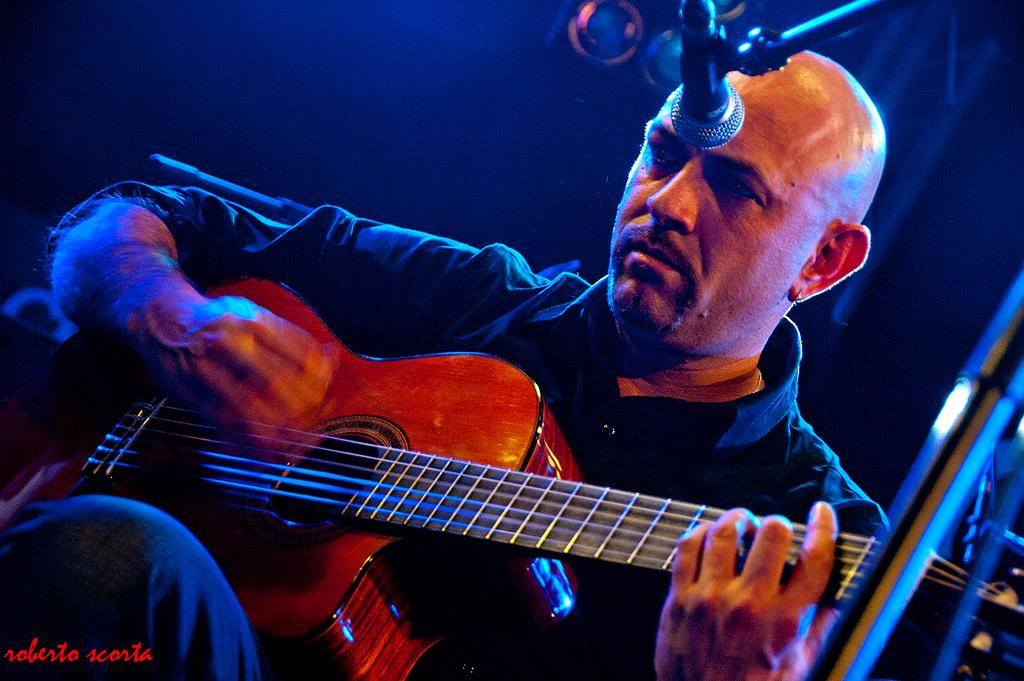What is the man in the image doing? The man is playing the guitar. What object is present in the image that is typically used for amplifying sound? There is a microphone in the image. How many wings can be seen on the man in the image? There are no wings visible on the man in the image. What type of mountain is visible in the background of the image? There is no mountain present in the image; it features a man playing the guitar and a microphone. 